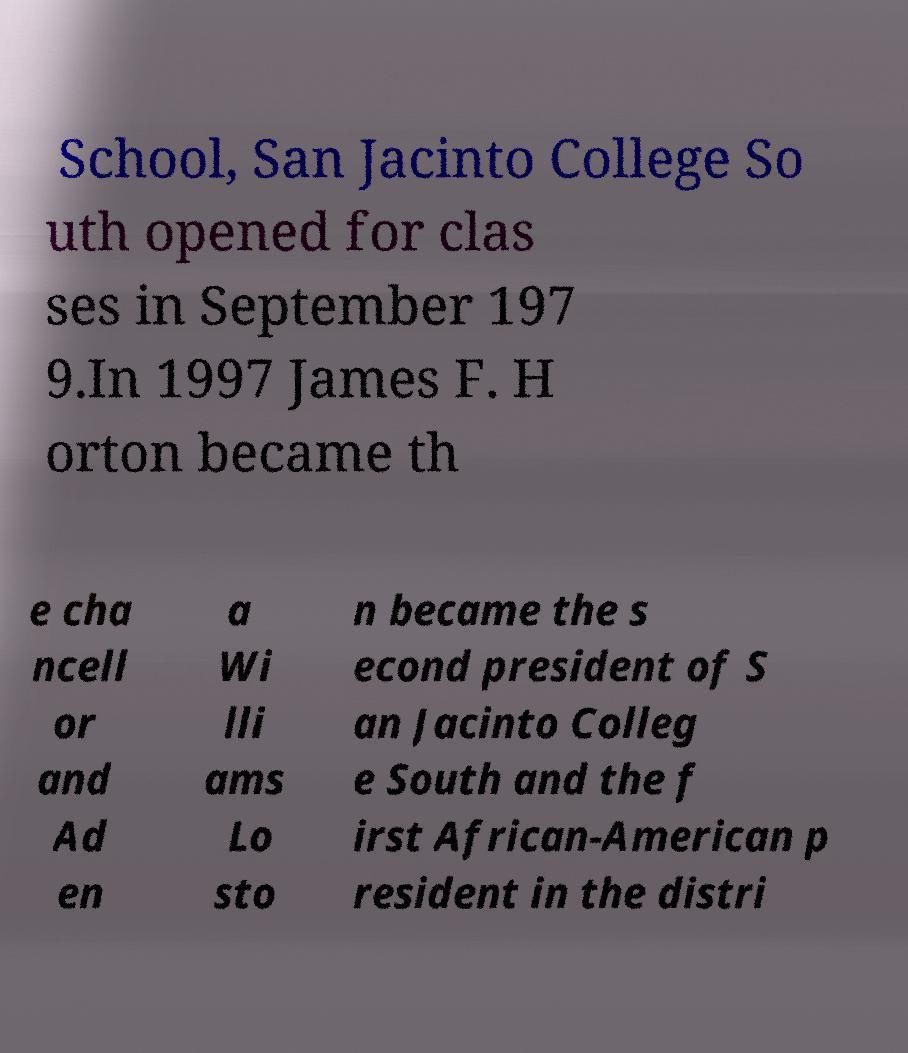For documentation purposes, I need the text within this image transcribed. Could you provide that? School, San Jacinto College So uth opened for clas ses in September 197 9.In 1997 James F. H orton became th e cha ncell or and Ad en a Wi lli ams Lo sto n became the s econd president of S an Jacinto Colleg e South and the f irst African-American p resident in the distri 